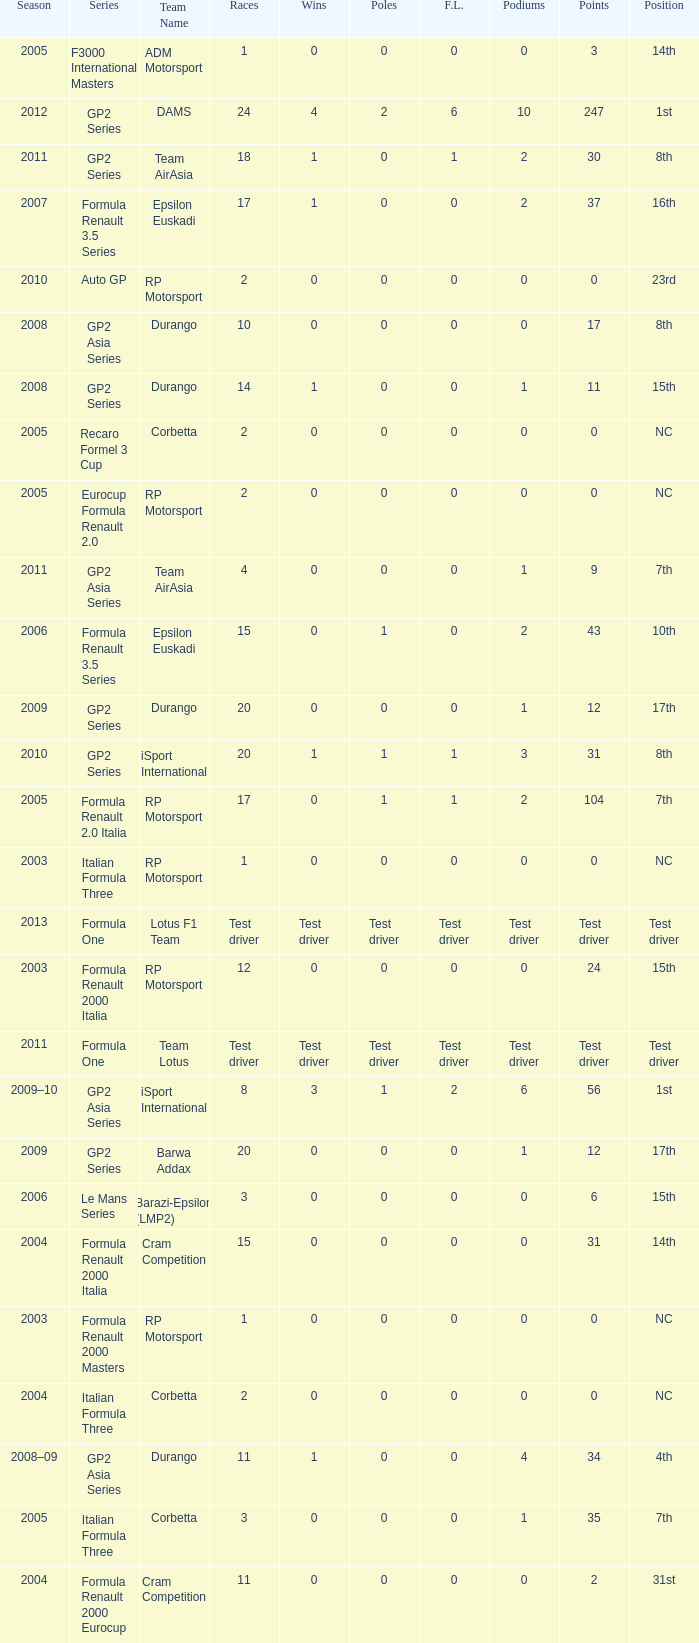What is the number of wins with a 0 F.L., 0 poles, a position of 7th, and 35 points? 0.0. 